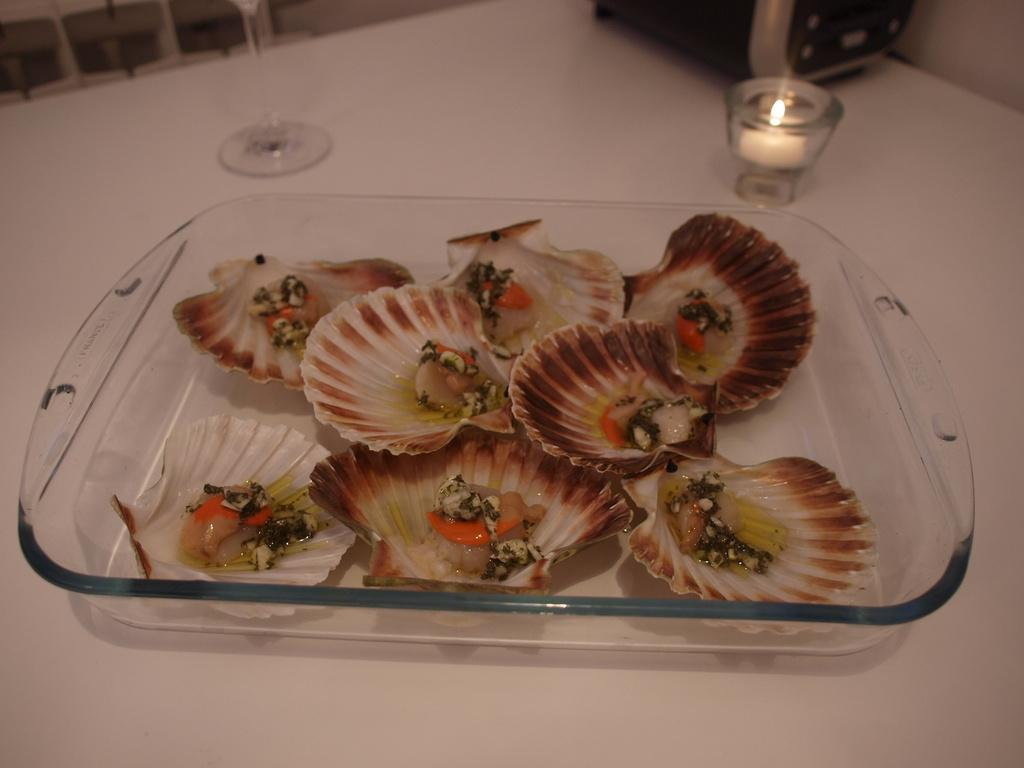What objects are on the glass tray in the image? There are seashells on a glass tray in the image. What other objects are near the tray? There is a candle and a glass beside the tray. What type of ball can be seen on the sidewalk in the image? There is no ball or sidewalk present in the image; it only features seashells on a glass tray, a candle, and a glass. 